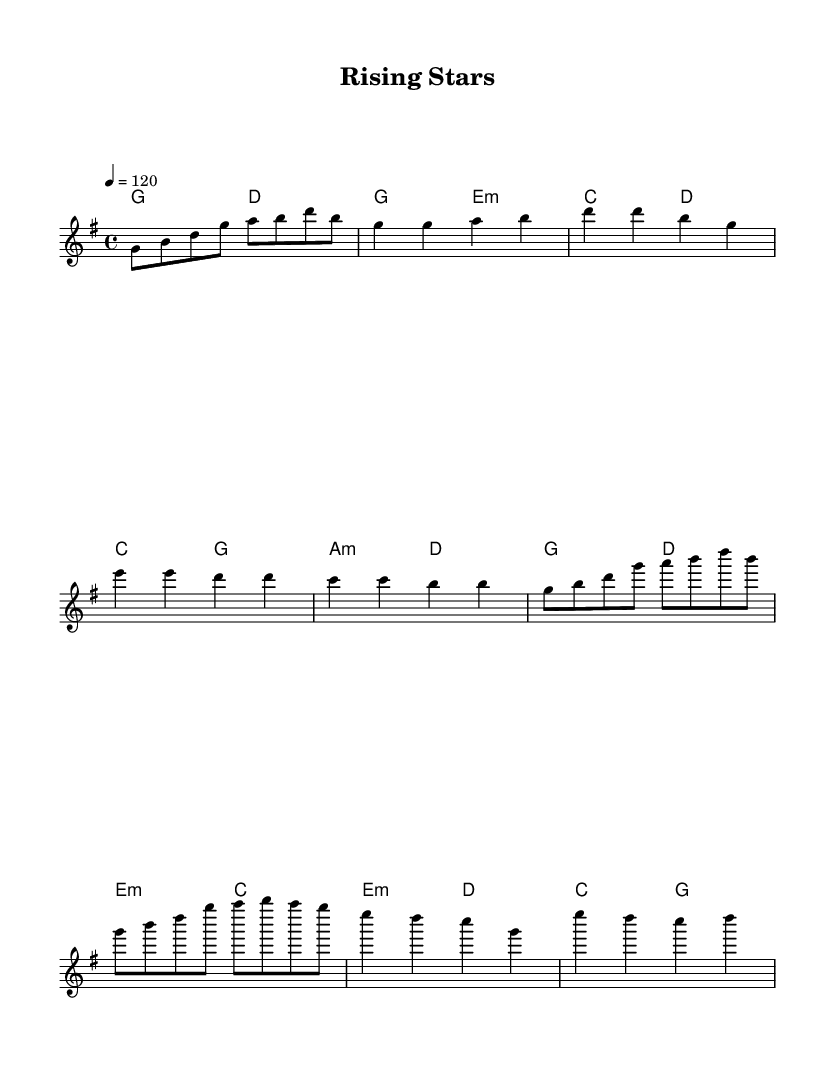What is the key signature of this music? The key signature is indicated by the number of sharps or flats in the staff. In this case, there are no sharps or flats, indicating that the piece is in G major.
Answer: G major What is the time signature? The time signature is found at the beginning of the piece, represented by the numbers. In this score, it is shown as 4/4, meaning there are four beats per measure and a quarter note gets one beat.
Answer: 4/4 What is the tempo marking? The tempo marking is indicated at the beginning of the piece as a number followed by a note value. Here, it shows "4 = 120," meaning there are 120 beats per minute, with the quarter note being one beat.
Answer: 120 How many measures are in the chorus? The chorus is identified by the repeated melodic and harmonic sections. By counting the measures used in the chorus, we find that there are 4 measures listed in this section.
Answer: 4 Which section comes after the verse? The structure of the piece follows a common K-Pop format, with sections identified in a linear manner. After the verse, the next labeled section is the pre-chorus.
Answer: Pre-Chorus What is the harmonic structure of the bridge? The harmonic structure in the bridge is determined by the chords written below the melody. Analyzing the chords reveals that the bridge's harmonic structure consists of E minor, D major, and C major.
Answer: E minor, D major, C major 